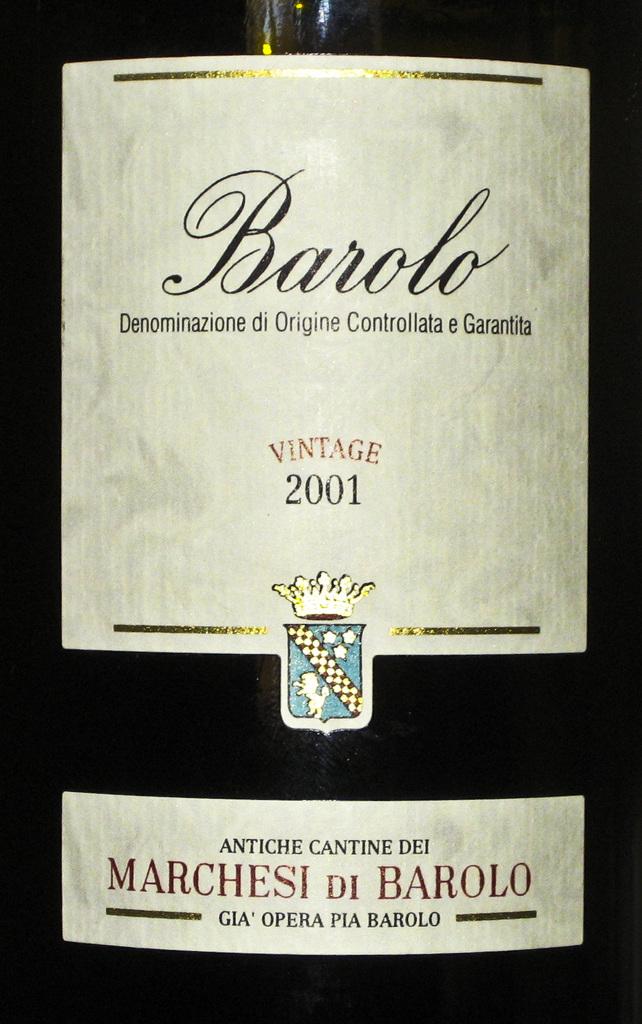What kind of wine is the label of?
Offer a terse response. Barolo. What year is this wine?
Make the answer very short. 2001. 